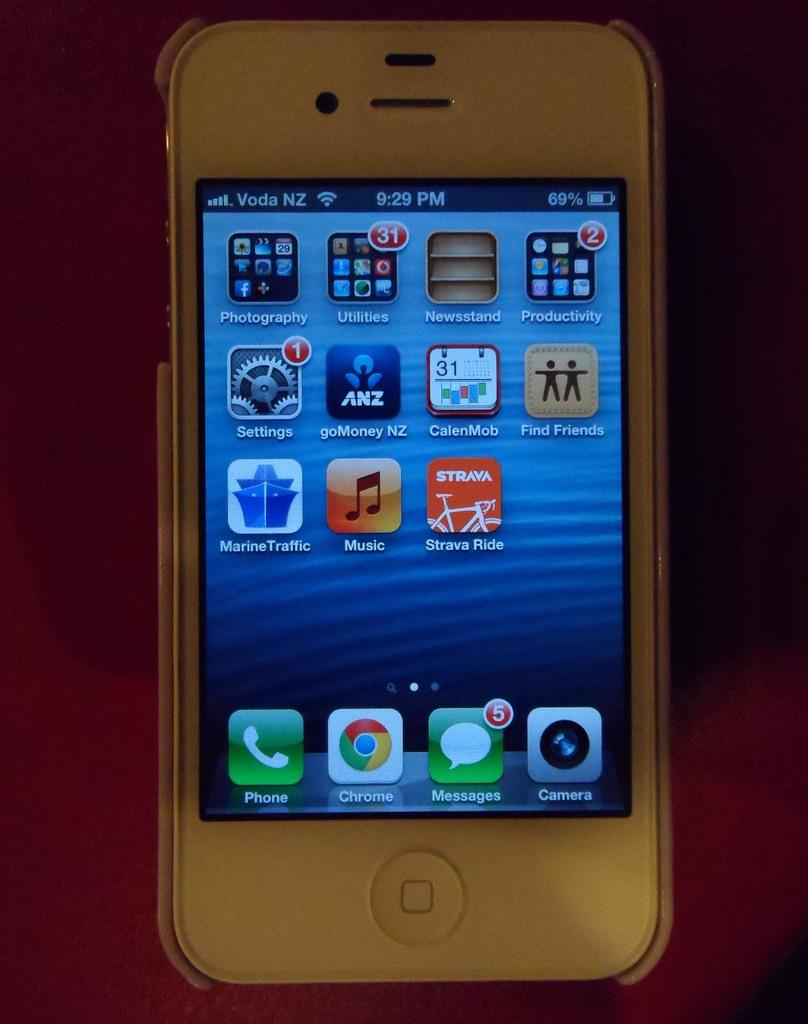What electronic device is visible in the image? There is a mobile phone in the image. Where is the mobile phone located? The mobile phone is placed on a table. What type of treatment is being administered to the tongue in the image? There is no tongue or treatment present in the image; it only features a mobile phone placed on a table. 